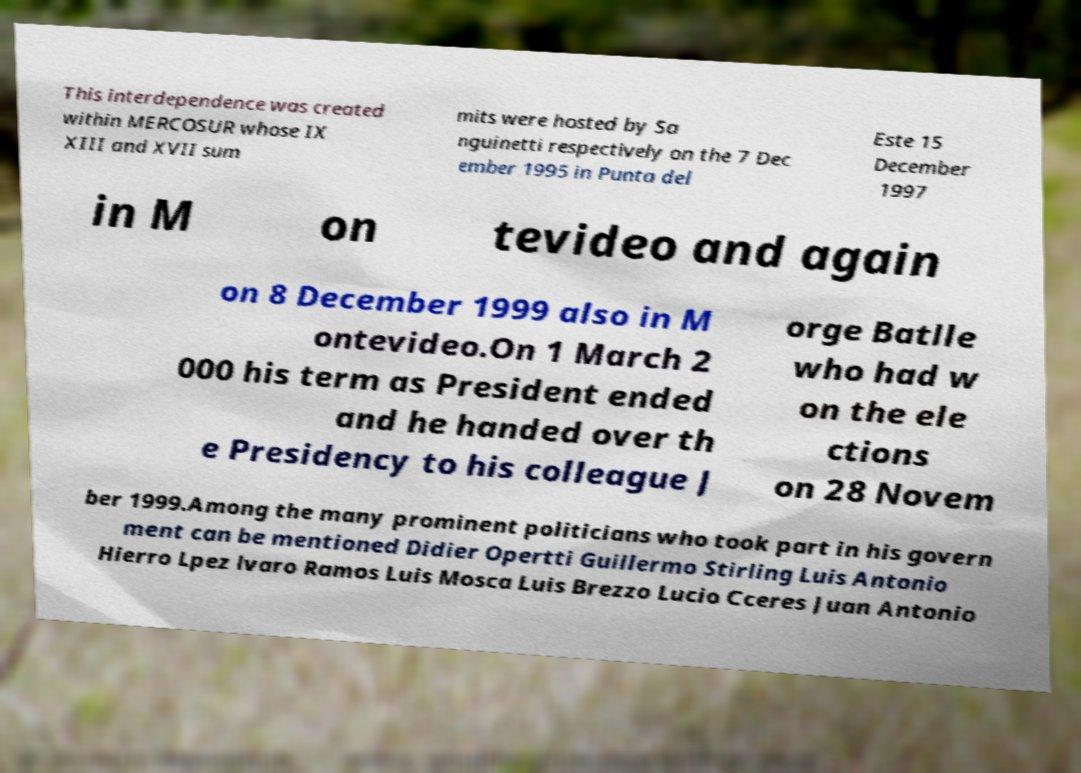Please read and relay the text visible in this image. What does it say? This interdependence was created within MERCOSUR whose IX XIII and XVII sum mits were hosted by Sa nguinetti respectively on the 7 Dec ember 1995 in Punta del Este 15 December 1997 in M on tevideo and again on 8 December 1999 also in M ontevideo.On 1 March 2 000 his term as President ended and he handed over th e Presidency to his colleague J orge Batlle who had w on the ele ctions on 28 Novem ber 1999.Among the many prominent politicians who took part in his govern ment can be mentioned Didier Opertti Guillermo Stirling Luis Antonio Hierro Lpez lvaro Ramos Luis Mosca Luis Brezzo Lucio Cceres Juan Antonio 